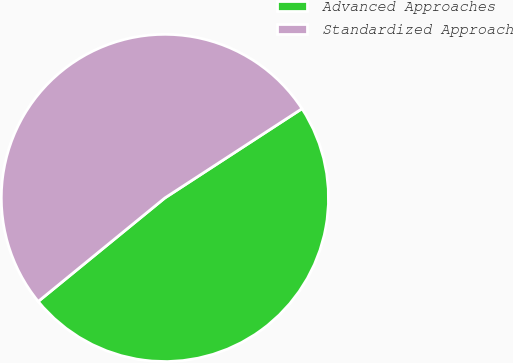Convert chart to OTSL. <chart><loc_0><loc_0><loc_500><loc_500><pie_chart><fcel>Advanced Approaches<fcel>Standardized Approach<nl><fcel>48.28%<fcel>51.72%<nl></chart> 